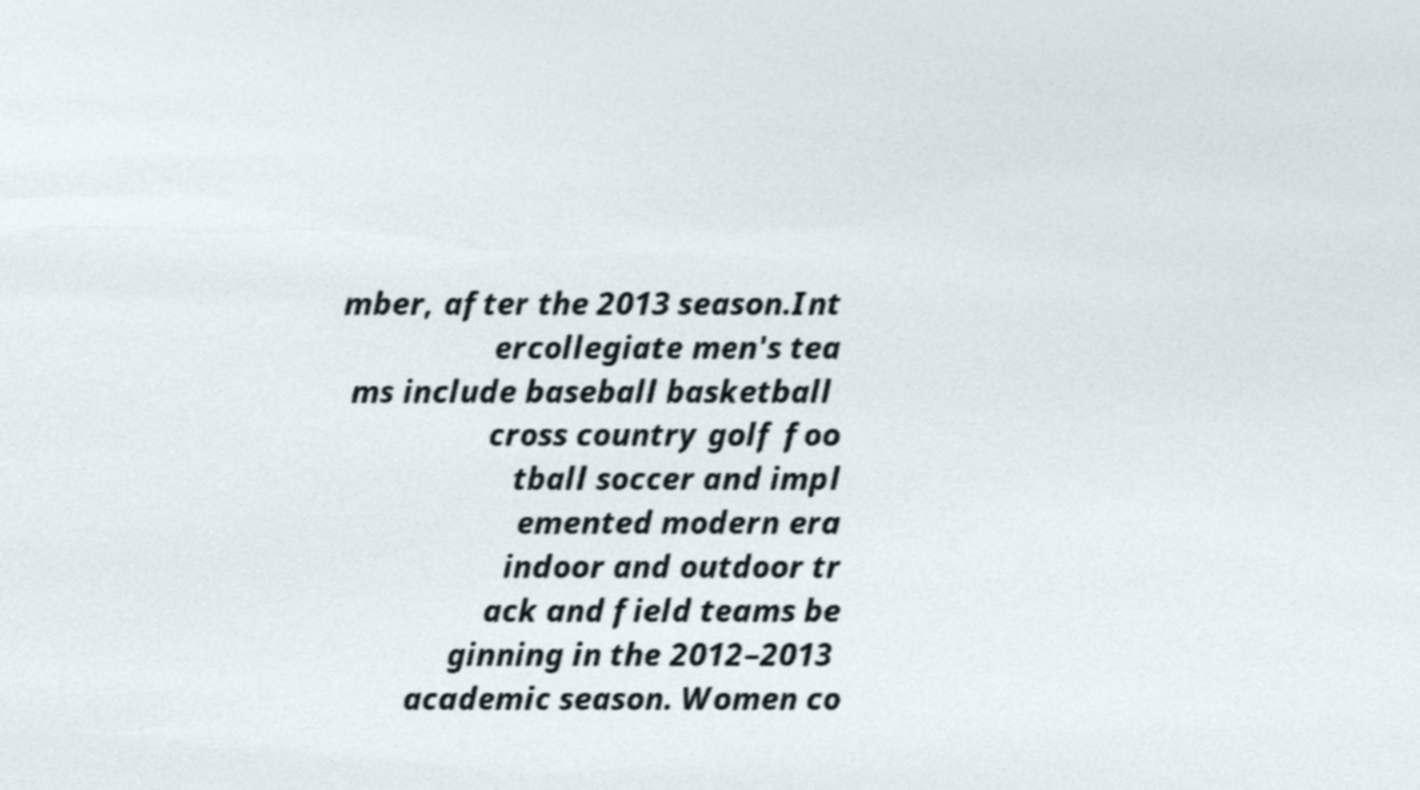Please identify and transcribe the text found in this image. mber, after the 2013 season.Int ercollegiate men's tea ms include baseball basketball cross country golf foo tball soccer and impl emented modern era indoor and outdoor tr ack and field teams be ginning in the 2012–2013 academic season. Women co 